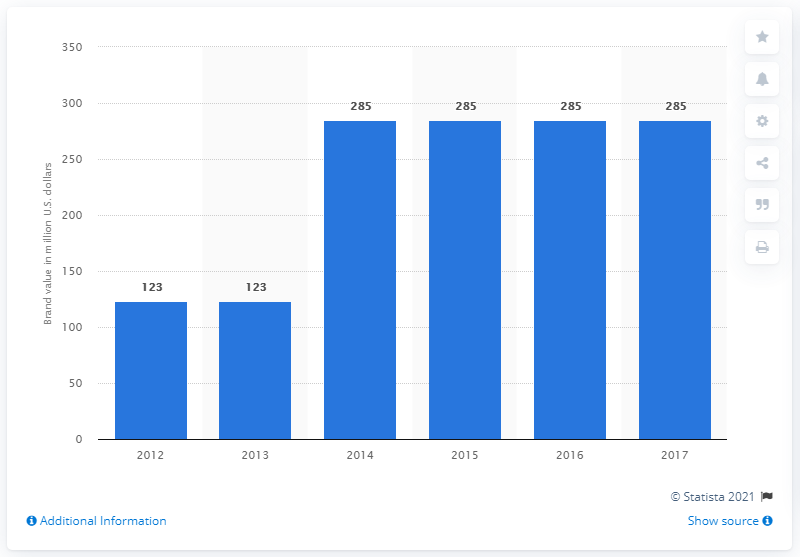Point out several critical features in this image. In 2017, the brand value of the Winter Olympic Games was estimated to be 285. 